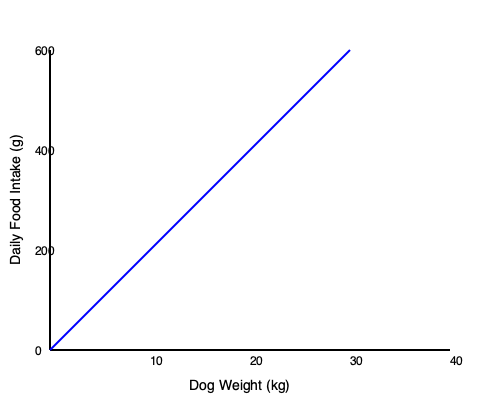Your dog weighs 25 kg, and you're planning a 2-week vacation. Based on the graph showing the relationship between dog weight and daily food intake, calculate the total volume of dog food needed for the vacation period if the dog food has a density of 0.5 g/cm³. Express your answer in liters (L). To solve this problem, we'll follow these steps:

1. Determine the daily food intake for a 25 kg dog from the graph:
   - At 25 kg, the daily food intake is approximately 375 g

2. Calculate the total food needed for 2 weeks:
   - 2 weeks = 14 days
   - Total food = Daily intake × Number of days
   - Total food = 375 g × 14 = 5250 g

3. Convert the mass of food to volume using the given density:
   - Density = Mass / Volume
   - 0.5 g/cm³ = 5250 g / Volume
   - Volume = 5250 g ÷ 0.5 g/cm³ = 10500 cm³

4. Convert cm³ to liters:
   - 1 L = 1000 cm³
   - Volume in liters = 10500 cm³ ÷ 1000 cm³/L = 10.5 L

Therefore, the total volume of dog food needed for the 2-week vacation is 10.5 L.
Answer: 10.5 L 